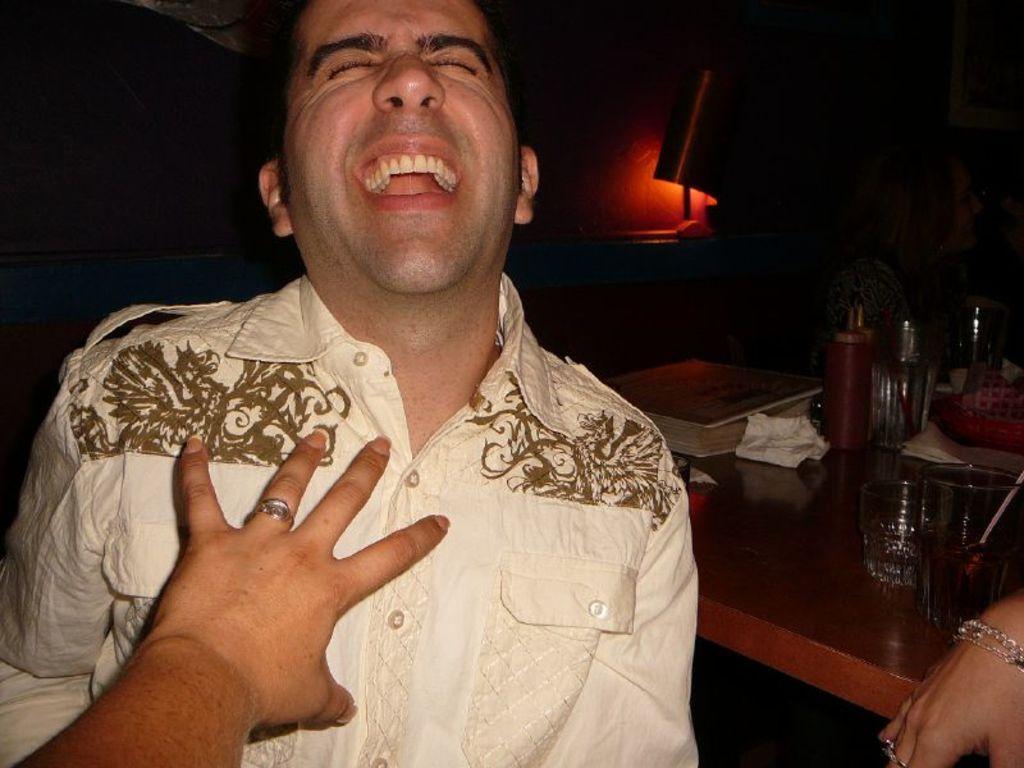Can you describe this image briefly? As we can see in the image in the front there is a man wearing white color shirt and on the right side there is a table. On table there are glasses and tray. 